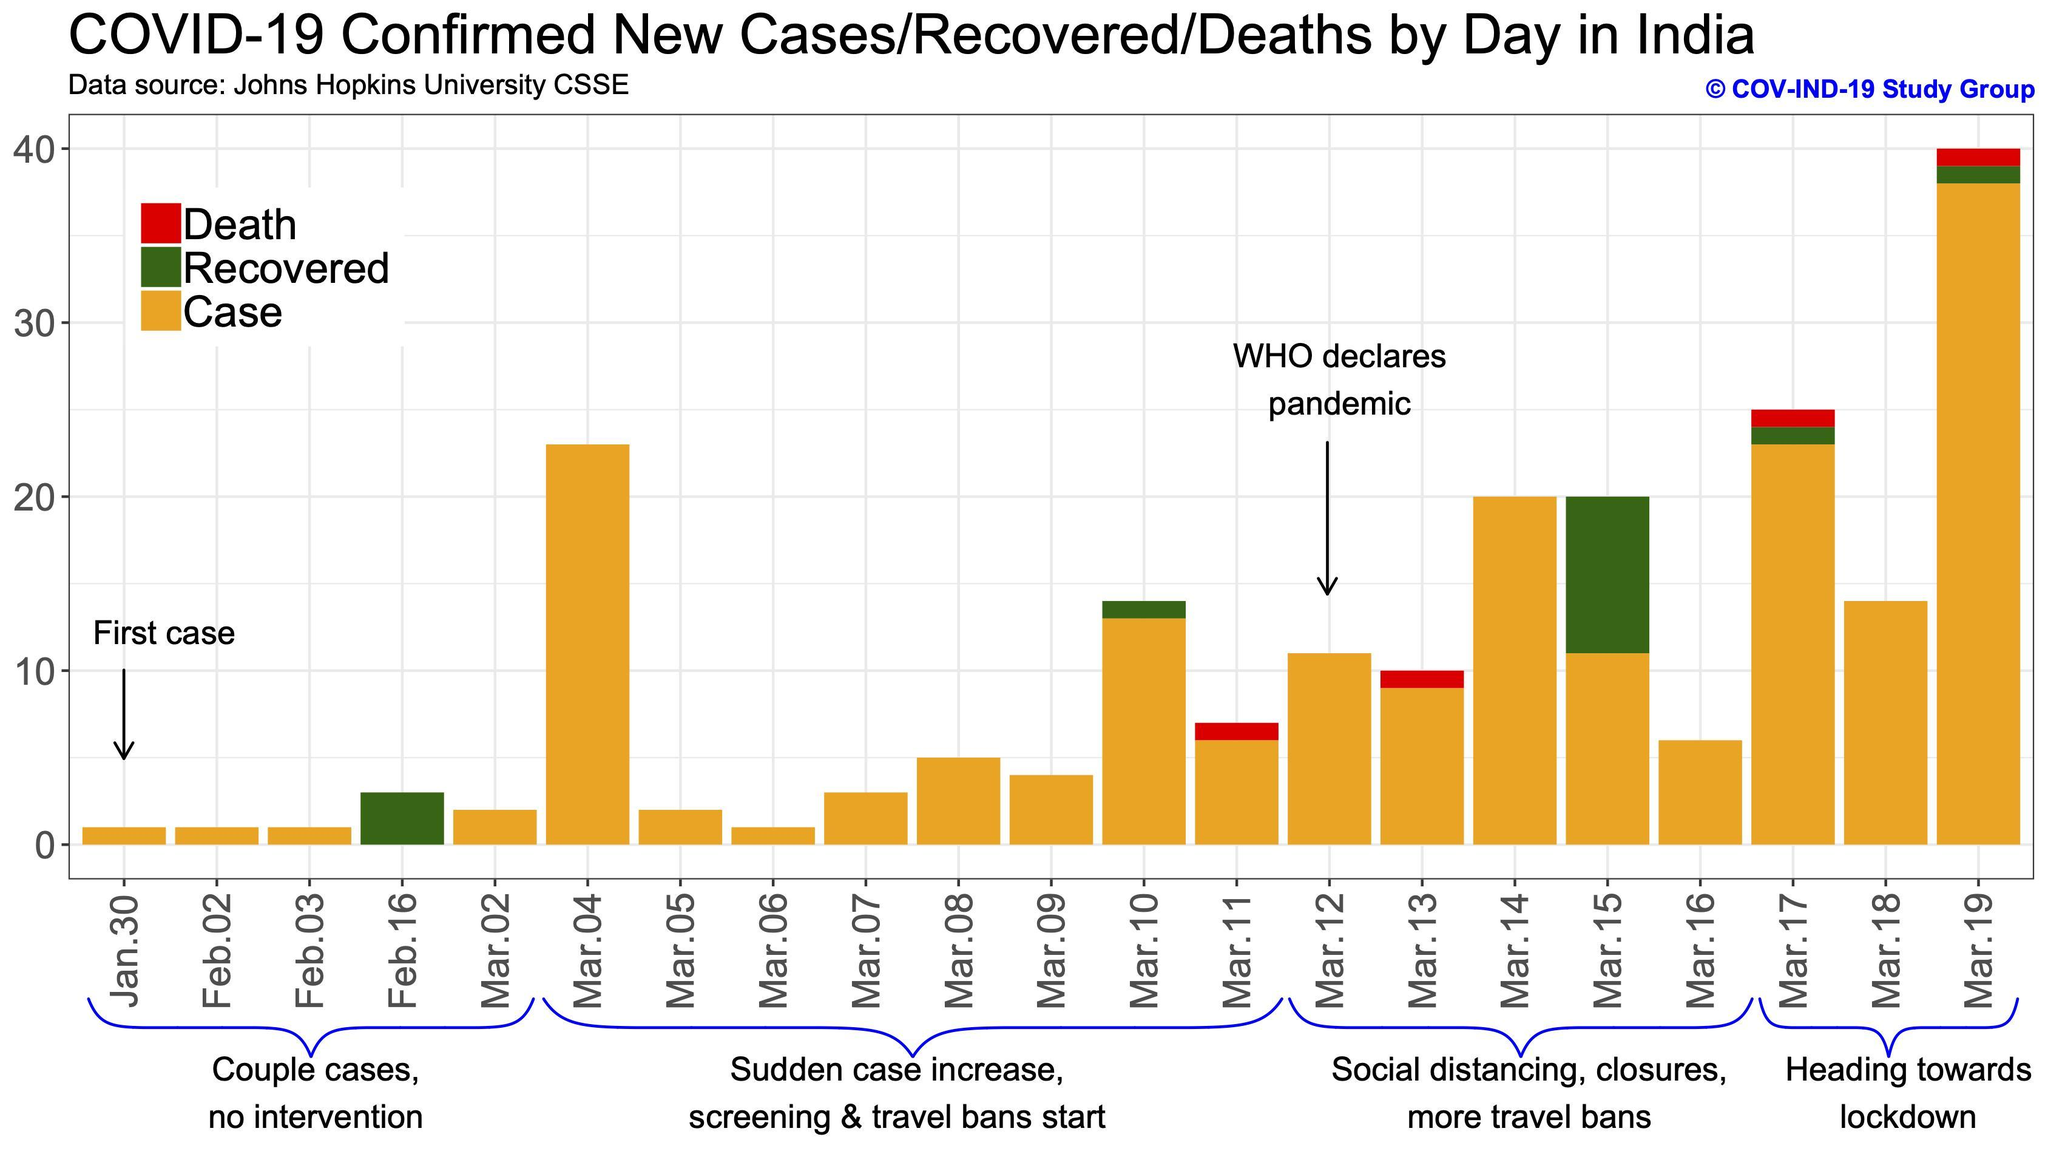what is the number of cases reported on March 8th?
Answer the question with a short phrase. 5 what is the number of cases reported on March 15th? 11 what is the total number of death from January 30 to March 19? 4 what is the number of cases reported on March 9th? 4 What is the number of cases on the day when WHO declared COVID-19 as pandemic? 11 what is the number of cases recovered on March 10th? 1 What is the total number of cases reported on March 6th and March 7th added together? 4 What is the total number of infected cases, recovered cases and deaths of March 19th added together? 40 what is the number of cases recovered on March 15th? 9 what is the number of cases reported on March 4th? 23 what is the total number of recovered cases from January 30 to March 19? 15 Based on which days' data government decided to go for lockdown? Mar.17, Mar.18, Mar.19 What is the total number of cases reported on March 8th and March 9th added together? 9 what is the number of cases reported on March 19th? 38 what is the number of cases recovered on March 17th? 1 